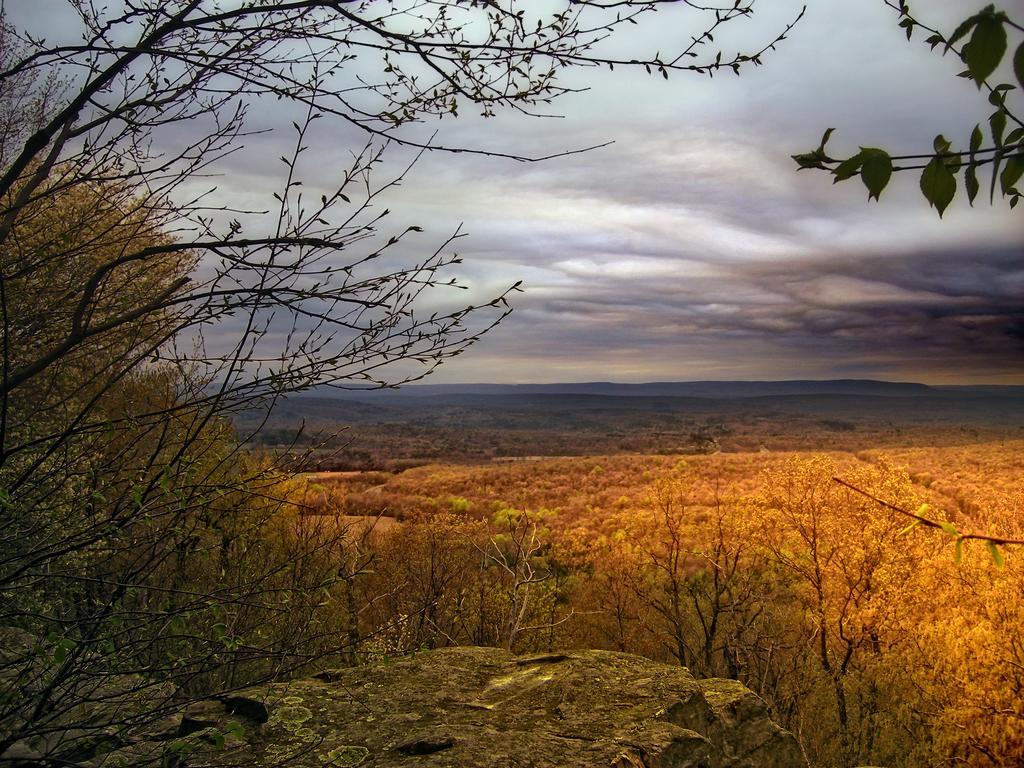Please provide a concise description of this image. In this picture I can see trees, hills, and in the background there is sky. 